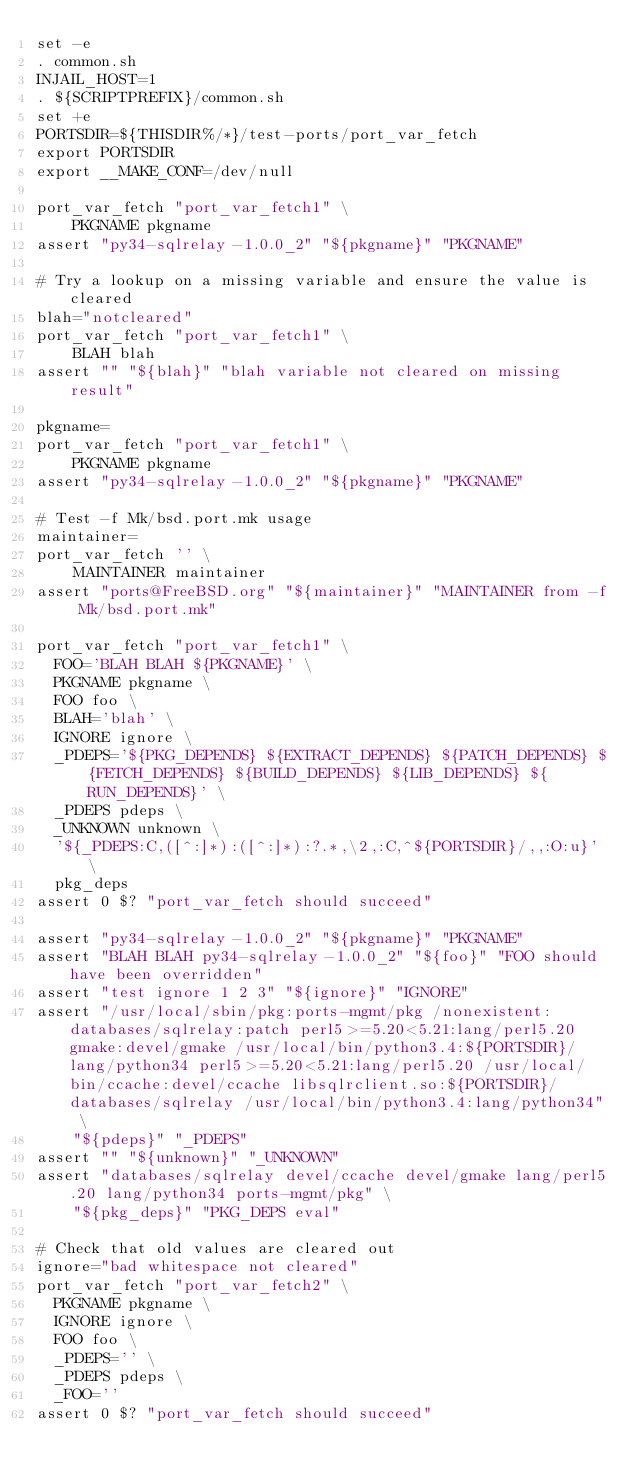Convert code to text. <code><loc_0><loc_0><loc_500><loc_500><_Bash_>set -e
. common.sh
INJAIL_HOST=1
. ${SCRIPTPREFIX}/common.sh
set +e
PORTSDIR=${THISDIR%/*}/test-ports/port_var_fetch
export PORTSDIR
export __MAKE_CONF=/dev/null

port_var_fetch "port_var_fetch1" \
    PKGNAME pkgname
assert "py34-sqlrelay-1.0.0_2" "${pkgname}" "PKGNAME"

# Try a lookup on a missing variable and ensure the value is cleared
blah="notcleared"
port_var_fetch "port_var_fetch1" \
    BLAH blah
assert "" "${blah}" "blah variable not cleared on missing result"

pkgname=
port_var_fetch "port_var_fetch1" \
    PKGNAME pkgname
assert "py34-sqlrelay-1.0.0_2" "${pkgname}" "PKGNAME"

# Test -f Mk/bsd.port.mk usage
maintainer=
port_var_fetch '' \
    MAINTAINER maintainer
assert "ports@FreeBSD.org" "${maintainer}" "MAINTAINER from -f Mk/bsd.port.mk"

port_var_fetch "port_var_fetch1" \
	FOO='BLAH BLAH ${PKGNAME}' \
	PKGNAME pkgname \
	FOO foo \
	BLAH='blah' \
	IGNORE ignore \
	_PDEPS='${PKG_DEPENDS} ${EXTRACT_DEPENDS} ${PATCH_DEPENDS} ${FETCH_DEPENDS} ${BUILD_DEPENDS} ${LIB_DEPENDS} ${RUN_DEPENDS}' \
	_PDEPS pdeps \
	_UNKNOWN unknown \
	'${_PDEPS:C,([^:]*):([^:]*):?.*,\2,:C,^${PORTSDIR}/,,:O:u}' \
	pkg_deps
assert 0 $? "port_var_fetch should succeed"

assert "py34-sqlrelay-1.0.0_2" "${pkgname}" "PKGNAME"
assert "BLAH BLAH py34-sqlrelay-1.0.0_2" "${foo}" "FOO should have been overridden"
assert "test ignore 1 2 3" "${ignore}" "IGNORE"
assert "/usr/local/sbin/pkg:ports-mgmt/pkg /nonexistent:databases/sqlrelay:patch perl5>=5.20<5.21:lang/perl5.20  gmake:devel/gmake /usr/local/bin/python3.4:${PORTSDIR}/lang/python34 perl5>=5.20<5.21:lang/perl5.20 /usr/local/bin/ccache:devel/ccache libsqlrclient.so:${PORTSDIR}/databases/sqlrelay /usr/local/bin/python3.4:lang/python34" \
    "${pdeps}" "_PDEPS"
assert "" "${unknown}" "_UNKNOWN"
assert "databases/sqlrelay devel/ccache devel/gmake lang/perl5.20 lang/python34 ports-mgmt/pkg" \
    "${pkg_deps}" "PKG_DEPS eval"

# Check that old values are cleared out
ignore="bad whitespace not cleared"
port_var_fetch "port_var_fetch2" \
	PKGNAME pkgname \
	IGNORE ignore \
	FOO foo \
	_PDEPS='' \
	_PDEPS pdeps \
	_FOO=''
assert 0 $? "port_var_fetch should succeed"</code> 